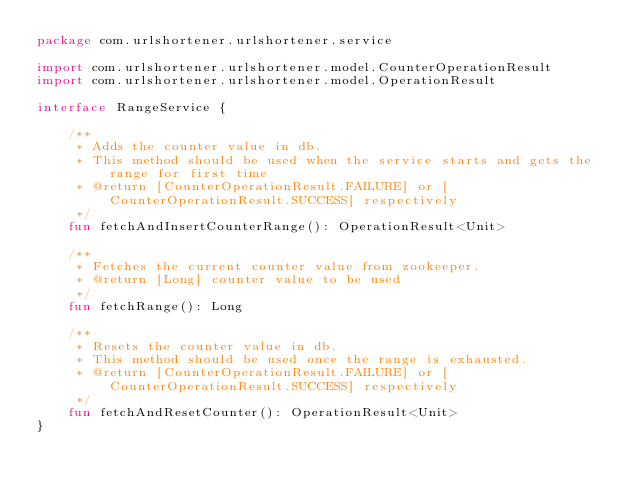Convert code to text. <code><loc_0><loc_0><loc_500><loc_500><_Kotlin_>package com.urlshortener.urlshortener.service

import com.urlshortener.urlshortener.model.CounterOperationResult
import com.urlshortener.urlshortener.model.OperationResult

interface RangeService {

    /**
     * Adds the counter value in db.
     * This method should be used when the service starts and gets the range for first time
     * @return [CounterOperationResult.FAILURE] or [CounterOperationResult.SUCCESS] respectively
     */
    fun fetchAndInsertCounterRange(): OperationResult<Unit>

    /**
     * Fetches the current counter value from zookeeper.
     * @return [Long] counter value to be used
     */
    fun fetchRange(): Long

    /**
     * Resets the counter value in db.
     * This method should be used once the range is exhausted.
     * @return [CounterOperationResult.FAILURE] or [CounterOperationResult.SUCCESS] respectively
     */
    fun fetchAndResetCounter(): OperationResult<Unit>
}
</code> 